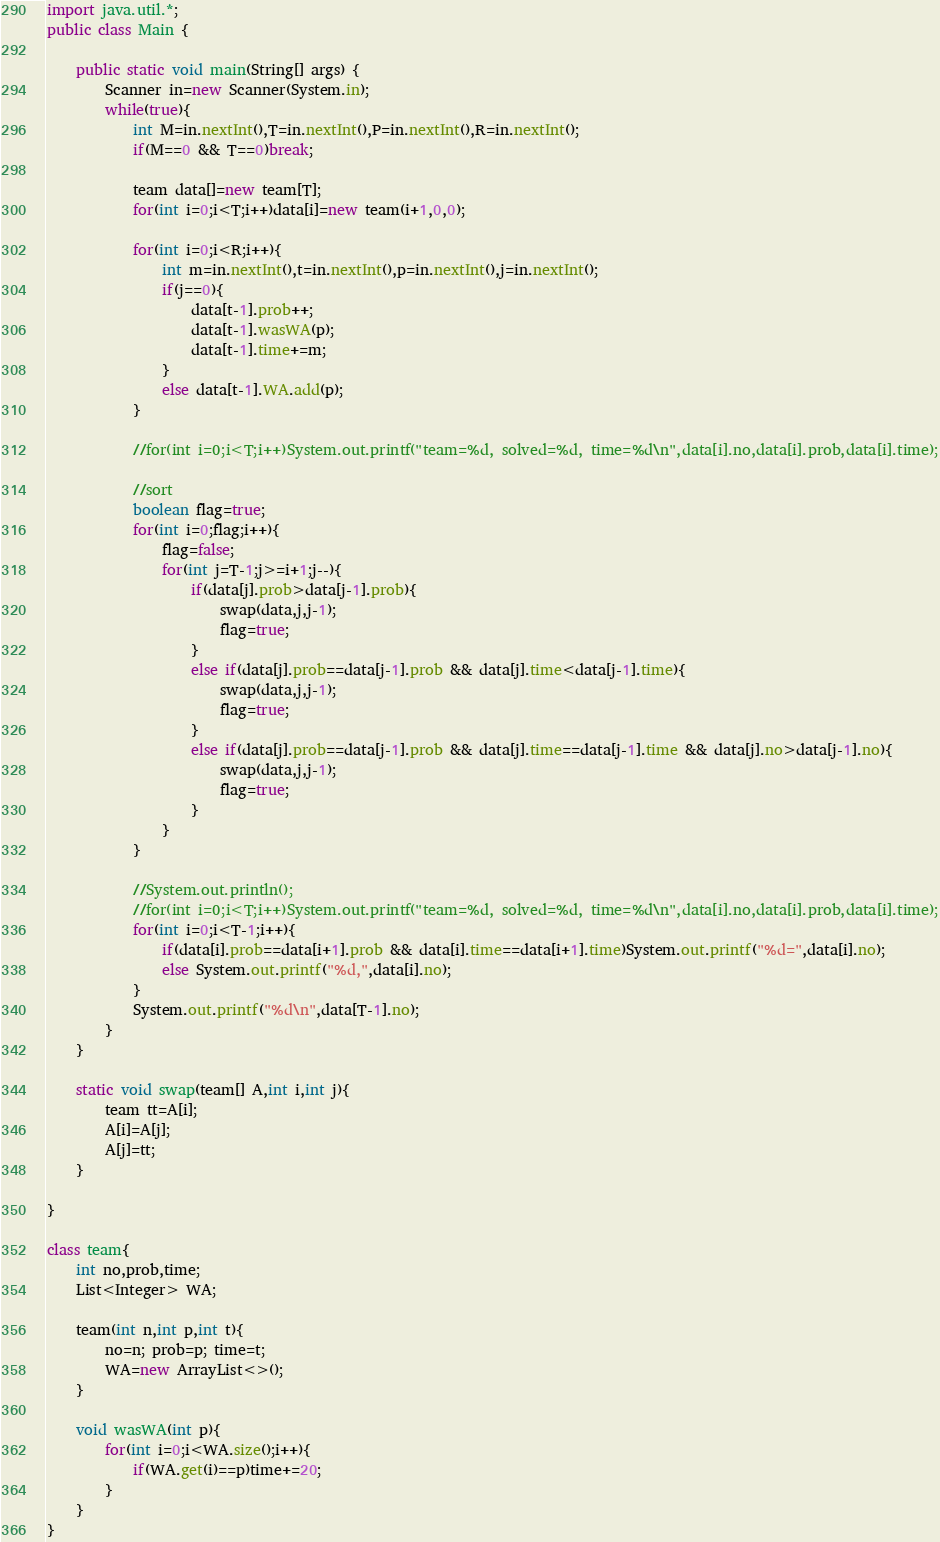<code> <loc_0><loc_0><loc_500><loc_500><_Java_>import java.util.*;
public class Main {

	public static void main(String[] args) {
		Scanner in=new Scanner(System.in);
		while(true){
			int M=in.nextInt(),T=in.nextInt(),P=in.nextInt(),R=in.nextInt();
			if(M==0 && T==0)break;

			team data[]=new team[T];
			for(int i=0;i<T;i++)data[i]=new team(i+1,0,0);

			for(int i=0;i<R;i++){
				int m=in.nextInt(),t=in.nextInt(),p=in.nextInt(),j=in.nextInt();
				if(j==0){
					data[t-1].prob++;
					data[t-1].wasWA(p);
					data[t-1].time+=m;
				}
				else data[t-1].WA.add(p);
			}
			
			//for(int i=0;i<T;i++)System.out.printf("team=%d, solved=%d, time=%d\n",data[i].no,data[i].prob,data[i].time);
			
			//sort
			boolean flag=true;
			for(int i=0;flag;i++){
				flag=false;
				for(int j=T-1;j>=i+1;j--){
					if(data[j].prob>data[j-1].prob){
						swap(data,j,j-1);
						flag=true;
					}
					else if(data[j].prob==data[j-1].prob && data[j].time<data[j-1].time){
						swap(data,j,j-1);
						flag=true;
					}
					else if(data[j].prob==data[j-1].prob && data[j].time==data[j-1].time && data[j].no>data[j-1].no){
						swap(data,j,j-1);
						flag=true;
					}
				}
			}
			
			//System.out.println();
			//for(int i=0;i<T;i++)System.out.printf("team=%d, solved=%d, time=%d\n",data[i].no,data[i].prob,data[i].time);
			for(int i=0;i<T-1;i++){
				if(data[i].prob==data[i+1].prob && data[i].time==data[i+1].time)System.out.printf("%d=",data[i].no);
				else System.out.printf("%d,",data[i].no);
			}
			System.out.printf("%d\n",data[T-1].no);
		}
	}
	
	static void swap(team[] A,int i,int j){
		team tt=A[i];
		A[i]=A[j];
		A[j]=tt;
	}

}

class team{
	int no,prob,time;
	List<Integer> WA;

	team(int n,int p,int t){
		no=n; prob=p; time=t;
		WA=new ArrayList<>();
	}

	void wasWA(int p){
		for(int i=0;i<WA.size();i++){
			if(WA.get(i)==p)time+=20;
		}
	}
}

</code> 